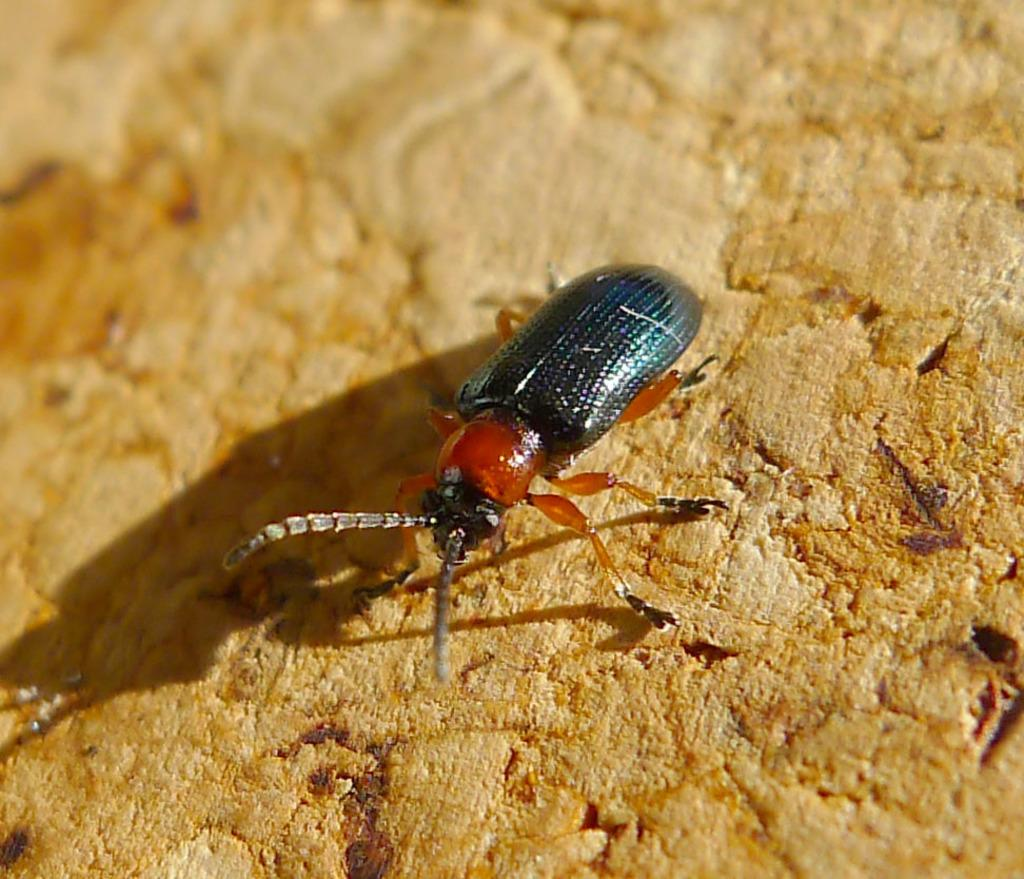What type of creature can be seen in the image? There is an insect in the image. Where is the insect located in the image? The insect is on a surface. What type of bread is being pointed at by the insect in the image? There is no bread present in the image, and the insect is not pointing at anything. 